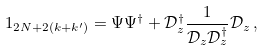<formula> <loc_0><loc_0><loc_500><loc_500>1 _ { 2 N + 2 ( k + k ^ { \prime } ) } = \Psi \Psi ^ { \dagger } + \mathcal { D } _ { z } ^ { \dagger } \frac { 1 } { \mathcal { D } _ { z } \mathcal { D } _ { z } ^ { \dagger } } \mathcal { D } _ { z } \, ,</formula> 